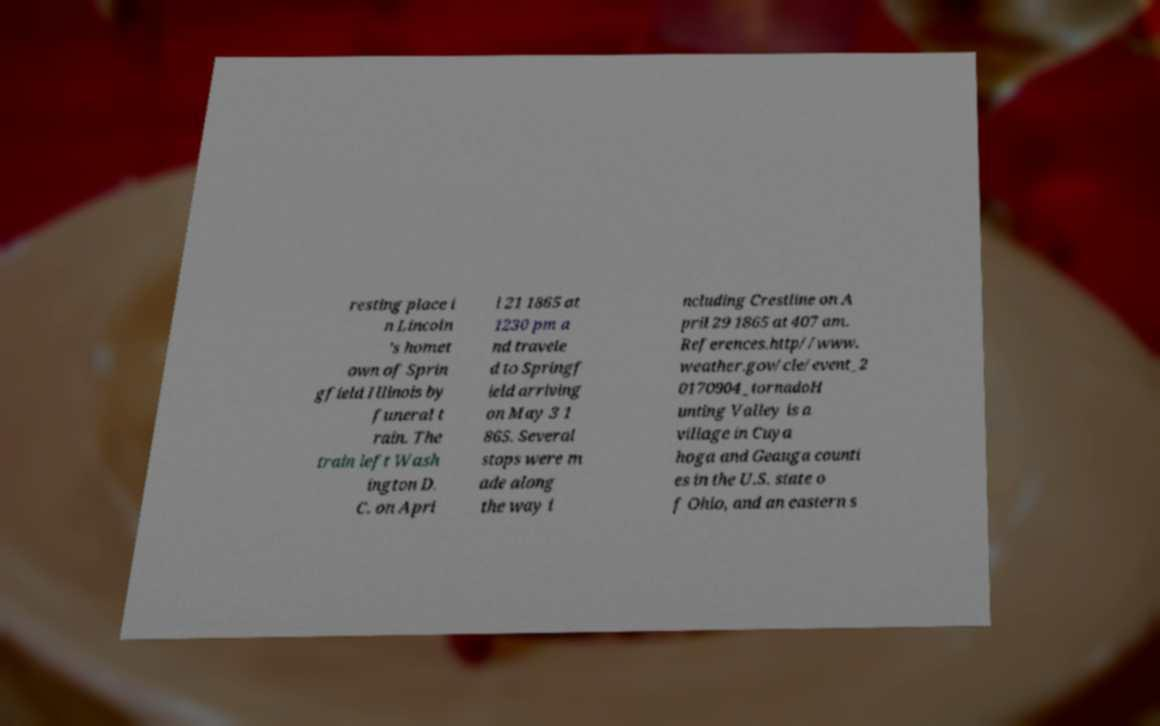I need the written content from this picture converted into text. Can you do that? resting place i n Lincoln 's homet own of Sprin gfield Illinois by funeral t rain. The train left Wash ington D. C. on Apri l 21 1865 at 1230 pm a nd travele d to Springf ield arriving on May 3 1 865. Several stops were m ade along the way i ncluding Crestline on A pril 29 1865 at 407 am. References.http//www. weather.gov/cle/event_2 0170904_tornadoH unting Valley is a village in Cuya hoga and Geauga counti es in the U.S. state o f Ohio, and an eastern s 